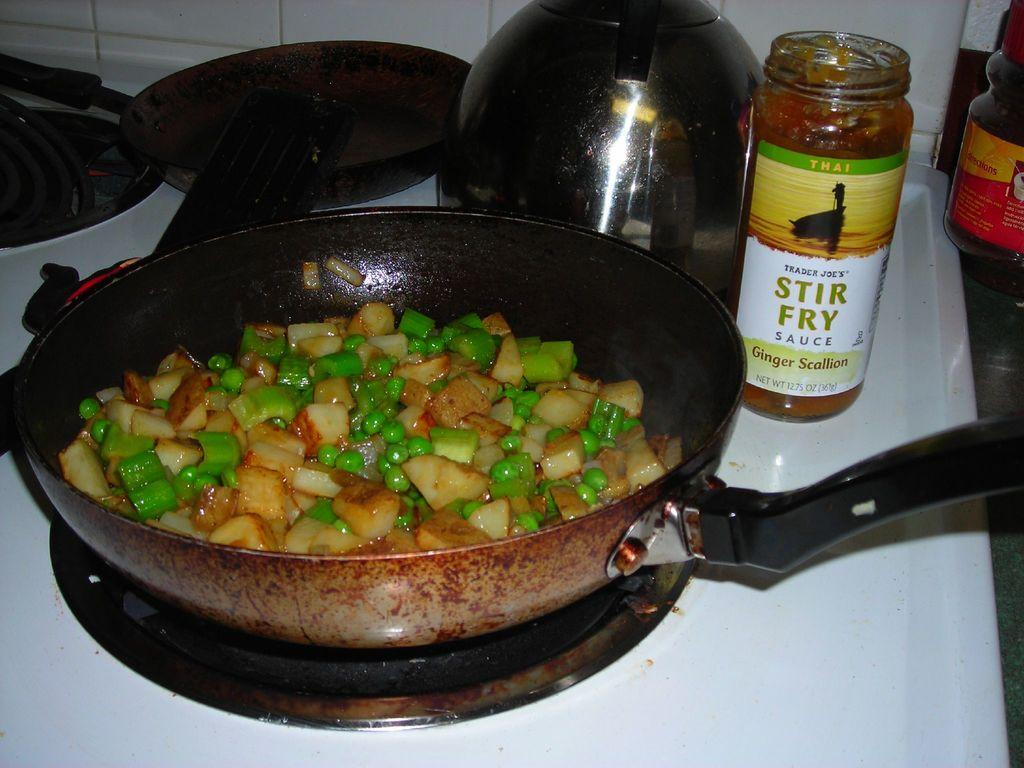What is being cooked in the pan on the stove in the image? There are food ingredients in a pan on the stove in the image. What else can be seen on the right side of the image? There is a glass jar on the right side of the image. What type of berry can be seen floating in the waves in the image? There are no berries or waves present in the image; it features a pan with food ingredients on the stove and a glass jar on the right side. 